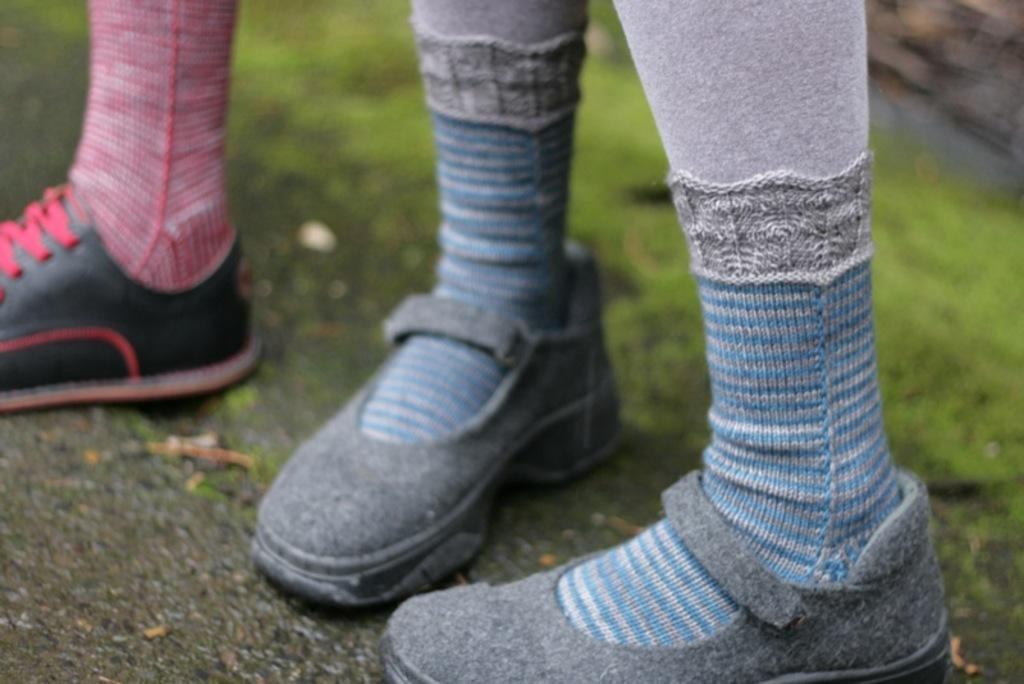What type of vegetation is present in the image? There is grass in the image. Can you describe the lower body parts of the people in the image? There are two people's legs in the image. What type of clothing is visible on the people's feet? There are socks visible in the image. What type of footwear is the people wearing? There are shoes in the image. What type of haircut does the giant have in the image? There are no giants present in the image, so it is not possible to determine their haircut. 